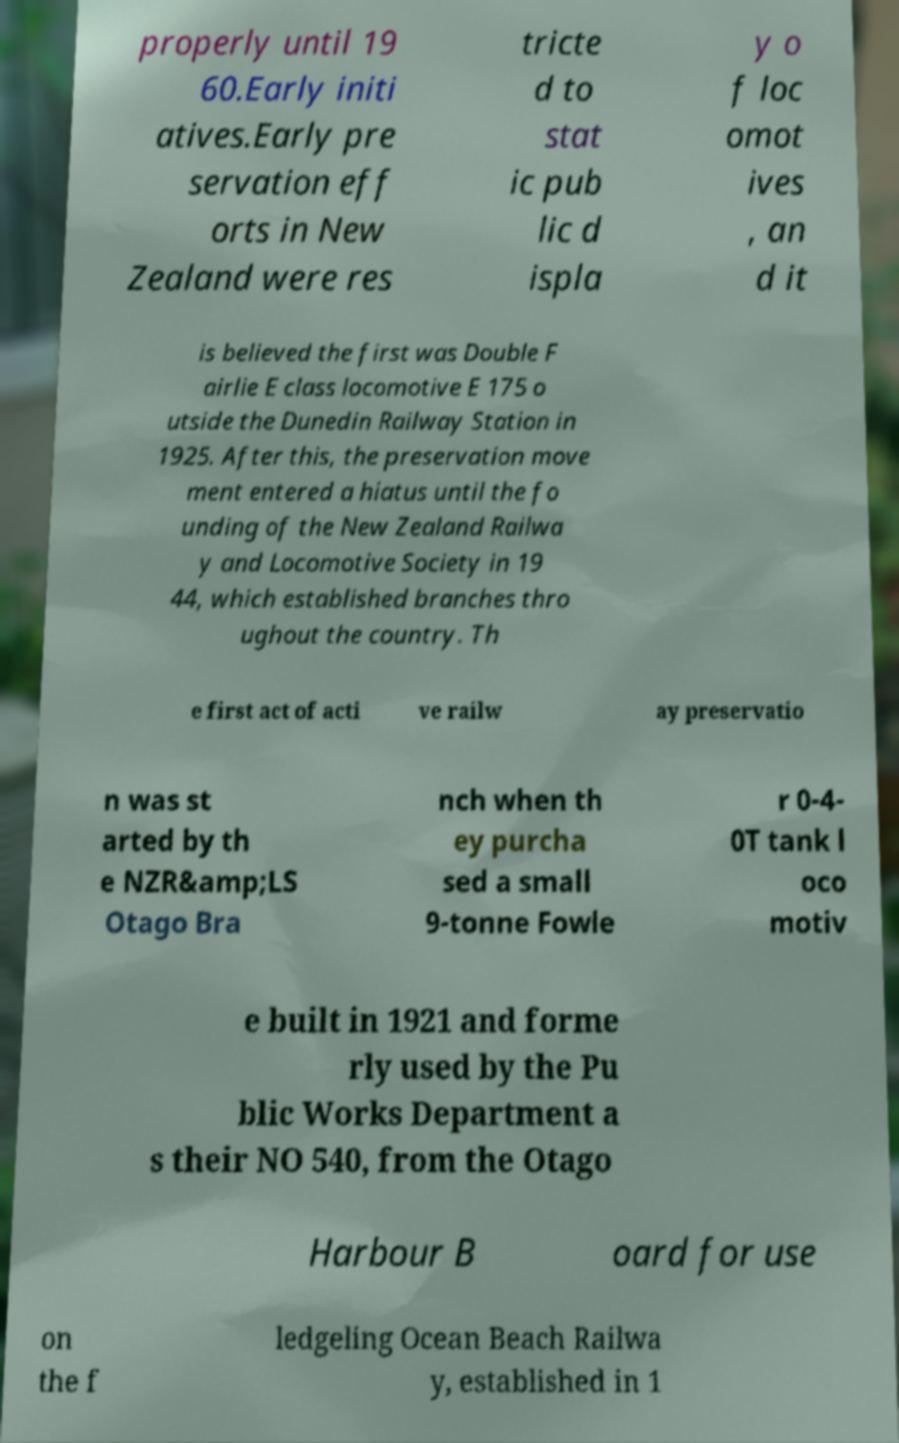I need the written content from this picture converted into text. Can you do that? properly until 19 60.Early initi atives.Early pre servation eff orts in New Zealand were res tricte d to stat ic pub lic d ispla y o f loc omot ives , an d it is believed the first was Double F airlie E class locomotive E 175 o utside the Dunedin Railway Station in 1925. After this, the preservation move ment entered a hiatus until the fo unding of the New Zealand Railwa y and Locomotive Society in 19 44, which established branches thro ughout the country. Th e first act of acti ve railw ay preservatio n was st arted by th e NZR&amp;LS Otago Bra nch when th ey purcha sed a small 9-tonne Fowle r 0-4- 0T tank l oco motiv e built in 1921 and forme rly used by the Pu blic Works Department a s their NO 540, from the Otago Harbour B oard for use on the f ledgeling Ocean Beach Railwa y, established in 1 